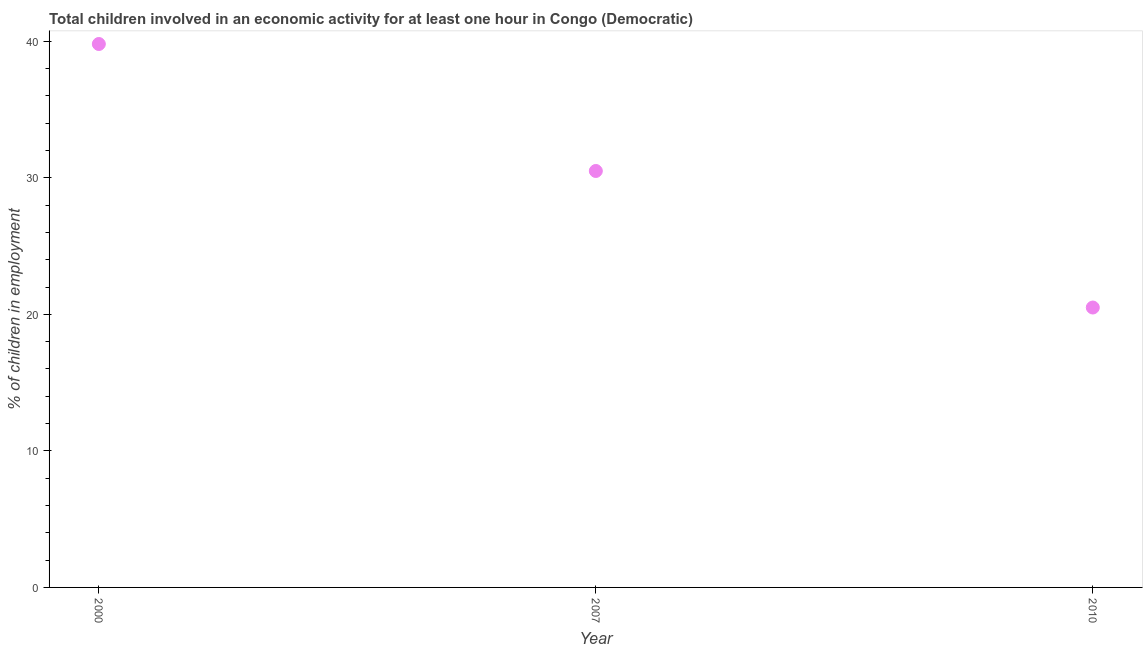What is the percentage of children in employment in 2010?
Provide a short and direct response. 20.5. Across all years, what is the maximum percentage of children in employment?
Make the answer very short. 39.8. What is the sum of the percentage of children in employment?
Keep it short and to the point. 90.8. What is the difference between the percentage of children in employment in 2000 and 2010?
Your answer should be compact. 19.3. What is the average percentage of children in employment per year?
Your response must be concise. 30.27. What is the median percentage of children in employment?
Offer a terse response. 30.5. In how many years, is the percentage of children in employment greater than 38 %?
Give a very brief answer. 1. What is the ratio of the percentage of children in employment in 2007 to that in 2010?
Ensure brevity in your answer.  1.49. Is the percentage of children in employment in 2000 less than that in 2007?
Provide a succinct answer. No. What is the difference between the highest and the second highest percentage of children in employment?
Keep it short and to the point. 9.3. What is the difference between the highest and the lowest percentage of children in employment?
Offer a very short reply. 19.3. Does the percentage of children in employment monotonically increase over the years?
Provide a succinct answer. No. How many dotlines are there?
Make the answer very short. 1. How many years are there in the graph?
Keep it short and to the point. 3. What is the difference between two consecutive major ticks on the Y-axis?
Offer a very short reply. 10. Are the values on the major ticks of Y-axis written in scientific E-notation?
Your response must be concise. No. Does the graph contain grids?
Give a very brief answer. No. What is the title of the graph?
Offer a very short reply. Total children involved in an economic activity for at least one hour in Congo (Democratic). What is the label or title of the X-axis?
Your response must be concise. Year. What is the label or title of the Y-axis?
Your response must be concise. % of children in employment. What is the % of children in employment in 2000?
Offer a terse response. 39.8. What is the % of children in employment in 2007?
Your response must be concise. 30.5. What is the % of children in employment in 2010?
Make the answer very short. 20.5. What is the difference between the % of children in employment in 2000 and 2010?
Provide a short and direct response. 19.3. What is the difference between the % of children in employment in 2007 and 2010?
Keep it short and to the point. 10. What is the ratio of the % of children in employment in 2000 to that in 2007?
Offer a very short reply. 1.3. What is the ratio of the % of children in employment in 2000 to that in 2010?
Your response must be concise. 1.94. What is the ratio of the % of children in employment in 2007 to that in 2010?
Keep it short and to the point. 1.49. 